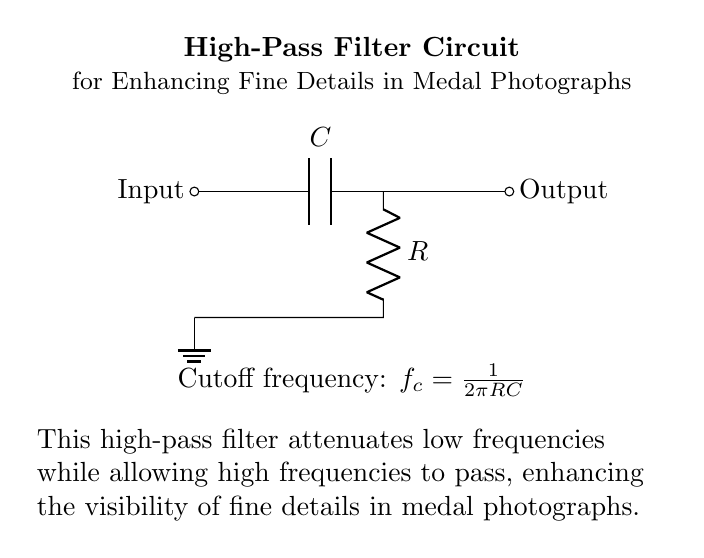What are the components of the circuit? The circuit contains a capacitor labeled C and a resistor labeled R. These components are specifically used in the construction of a high-pass filter.
Answer: Capacitor, Resistor What is the purpose of the high-pass filter in this circuit? The purpose of the high-pass filter is to attenuate low frequencies and allow high frequencies to pass, enhancing fine details in medal photographs.
Answer: Enhancing fine details What is the input to this high-pass filter circuit? The input is indicated at the left side of the circuit, where it connects to the capacitor. It likely receives a signal that includes both high and low frequency components.
Answer: Input signal What is the cutoff frequency formula for this circuit? The cutoff frequency is calculated using the formula \( f_c = \frac{1}{2\pi RC} \). This shows how the values of R and C affect the cutoff point between low and high frequencies.
Answer: Cutoff frequency formula How does the output relate to the input in this circuit? The output, located at the right side of the circuit, receives the signal after it has passed through the capacitor and resistor, which means it is the filtered version of the input. The high frequencies are transmitted, while the low frequencies are blocked.
Answer: Filtered output signal What effect does increasing the resistor value have on the filter? Increasing the resistor value R will lower the cutoff frequency \( f_c \), which means it will allow fewer higher frequencies to pass and might enhance lower frequency signals more than desired.
Answer: Lowers cutoff frequency What format is used to represent the ground in this circuit? The ground in this circuit is represented by a symbol that indicates a connection to the reference ground point, visually shown as a line with downward lines, pointing to the bottom.
Answer: Ground symbol 